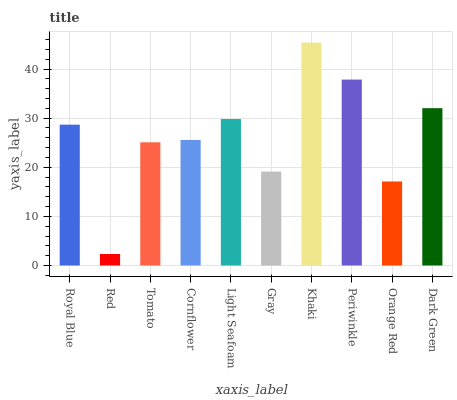Is Tomato the minimum?
Answer yes or no. No. Is Tomato the maximum?
Answer yes or no. No. Is Tomato greater than Red?
Answer yes or no. Yes. Is Red less than Tomato?
Answer yes or no. Yes. Is Red greater than Tomato?
Answer yes or no. No. Is Tomato less than Red?
Answer yes or no. No. Is Royal Blue the high median?
Answer yes or no. Yes. Is Cornflower the low median?
Answer yes or no. Yes. Is Dark Green the high median?
Answer yes or no. No. Is Orange Red the low median?
Answer yes or no. No. 